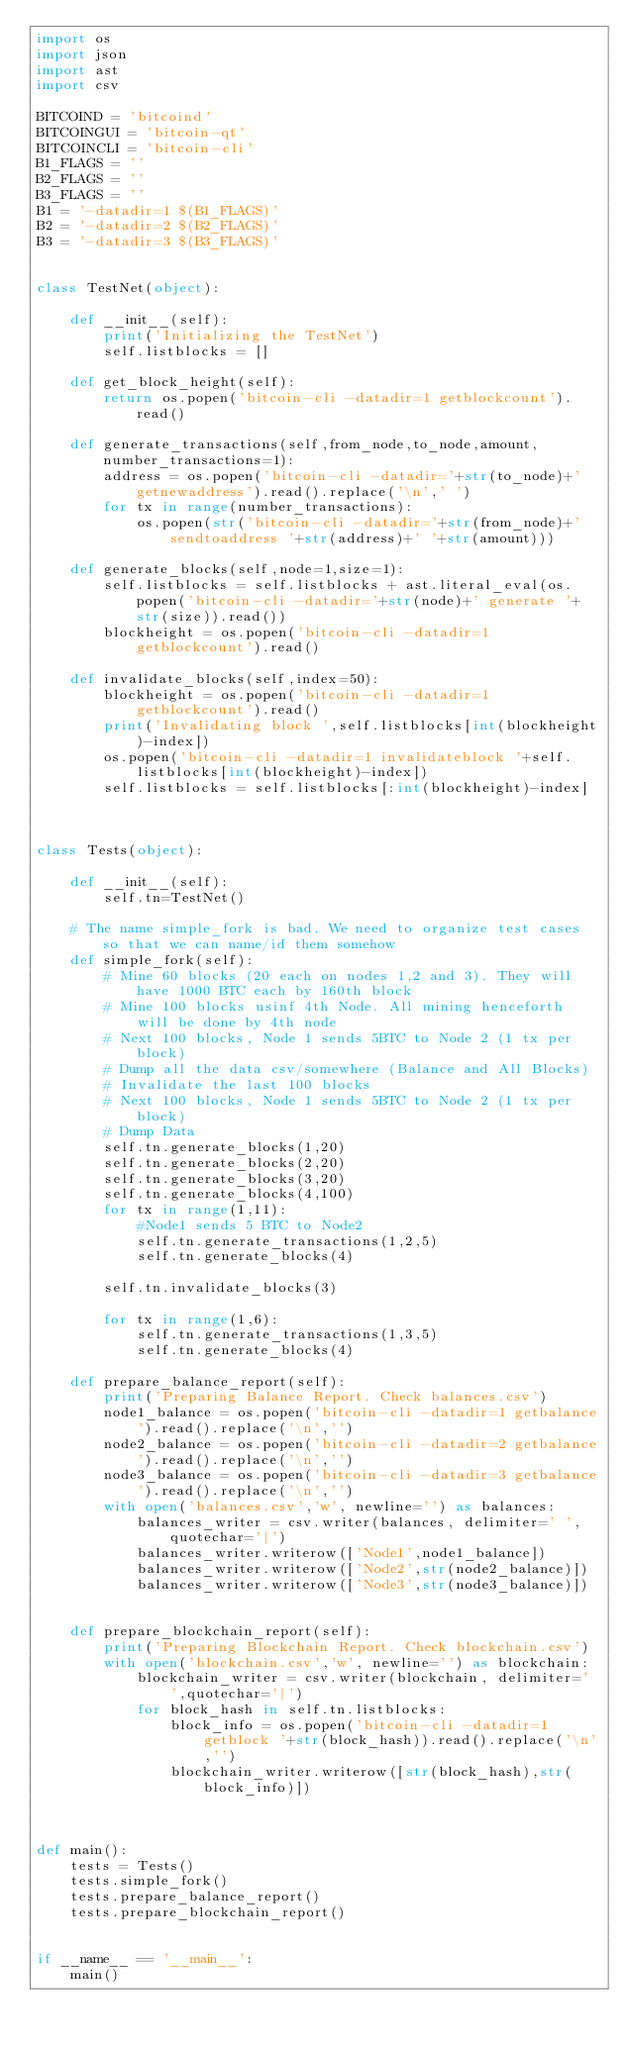<code> <loc_0><loc_0><loc_500><loc_500><_Python_>import os
import json
import ast
import csv

BITCOIND = 'bitcoind'
BITCOINGUI = 'bitcoin-qt'
BITCOINCLI = 'bitcoin-cli'
B1_FLAGS = ''
B2_FLAGS = ''
B3_FLAGS = ''
B1 = '-datadir=1 $(B1_FLAGS)'
B2 = '-datadir=2 $(B2_FLAGS)'
B3 = '-datadir=3 $(B3_FLAGS)'


class TestNet(object):

    def __init__(self):
        print('Initializing the TestNet')
        self.listblocks = []

    def get_block_height(self):
        return os.popen('bitcoin-cli -datadir=1 getblockcount').read()    

    def generate_transactions(self,from_node,to_node,amount,number_transactions=1):
        address = os.popen('bitcoin-cli -datadir='+str(to_node)+' getnewaddress').read().replace('\n',' ')
        for tx in range(number_transactions):
            os.popen(str('bitcoin-cli -datadir='+str(from_node)+' sendtoaddress '+str(address)+' '+str(amount)))       

    def generate_blocks(self,node=1,size=1):
        self.listblocks = self.listblocks + ast.literal_eval(os.popen('bitcoin-cli -datadir='+str(node)+' generate '+str(size)).read()) 
        blockheight = os.popen('bitcoin-cli -datadir=1 getblockcount').read()

    def invalidate_blocks(self,index=50):
        blockheight = os.popen('bitcoin-cli -datadir=1 getblockcount').read()
        print('Invalidating block ',self.listblocks[int(blockheight)-index])
        os.popen('bitcoin-cli -datadir=1 invalidateblock '+self.listblocks[int(blockheight)-index])
        self.listblocks = self.listblocks[:int(blockheight)-index]
        
        
    
class Tests(object):
    
    def __init__(self):
        self.tn=TestNet()	
    
    # The name simple_fork is bad. We need to organize test cases so that we can name/id them somehow
    def simple_fork(self):
        # Mine 60 blocks (20 each on nodes 1,2 and 3). They will have 1000 BTC each by 160th block
        # Mine 100 blocks usinf 4th Node. All mining henceforth will be done by 4th node
        # Next 100 blocks, Node 1 sends 5BTC to Node 2 (1 tx per block)
        # Dump all the data csv/somewhere (Balance and All Blocks)
        # Invalidate the last 100 blocks
        # Next 100 blocks, Node 1 sends 5BTC to Node 2 (1 tx per block)
        # Dump Data
        self.tn.generate_blocks(1,20)
        self.tn.generate_blocks(2,20)
        self.tn.generate_blocks(3,20)
        self.tn.generate_blocks(4,100)
        for tx in range(1,11):
            #Node1 sends 5 BTC to Node2
            self.tn.generate_transactions(1,2,5)
            self.tn.generate_blocks(4) 
        
        self.tn.invalidate_blocks(3)
        
        for tx in range(1,6):
            self.tn.generate_transactions(1,3,5)
            self.tn.generate_blocks(4)
        
    def prepare_balance_report(self):
        print('Preparing Balance Report. Check balances.csv')
        node1_balance = os.popen('bitcoin-cli -datadir=1 getbalance').read().replace('\n','')
        node2_balance = os.popen('bitcoin-cli -datadir=2 getbalance').read().replace('\n','')
        node3_balance = os.popen('bitcoin-cli -datadir=3 getbalance').read().replace('\n','')
        with open('balances.csv','w', newline='') as balances:
            balances_writer = csv.writer(balances, delimiter=' ',quotechar='|')
            balances_writer.writerow(['Node1',node1_balance]) 
            balances_writer.writerow(['Node2',str(node2_balance)]) 
            balances_writer.writerow(['Node3',str(node3_balance)])    

        
    def prepare_blockchain_report(self):
        print('Preparing Blockchain Report. Check blockchain.csv')
        with open('blockchain.csv','w', newline='') as blockchain:
            blockchain_writer = csv.writer(blockchain, delimiter=' ',quotechar='|')
            for block_hash in self.tn.listblocks:
                block_info = os.popen('bitcoin-cli -datadir=1 getblock '+str(block_hash)).read().replace('\n','')
                blockchain_writer.writerow([str(block_hash),str(block_info)])

    

def main():
    tests = Tests()
    tests.simple_fork()
    tests.prepare_balance_report()	
    tests.prepare_blockchain_report()
    

if __name__ == '__main__':
    main()
  


    	






</code> 